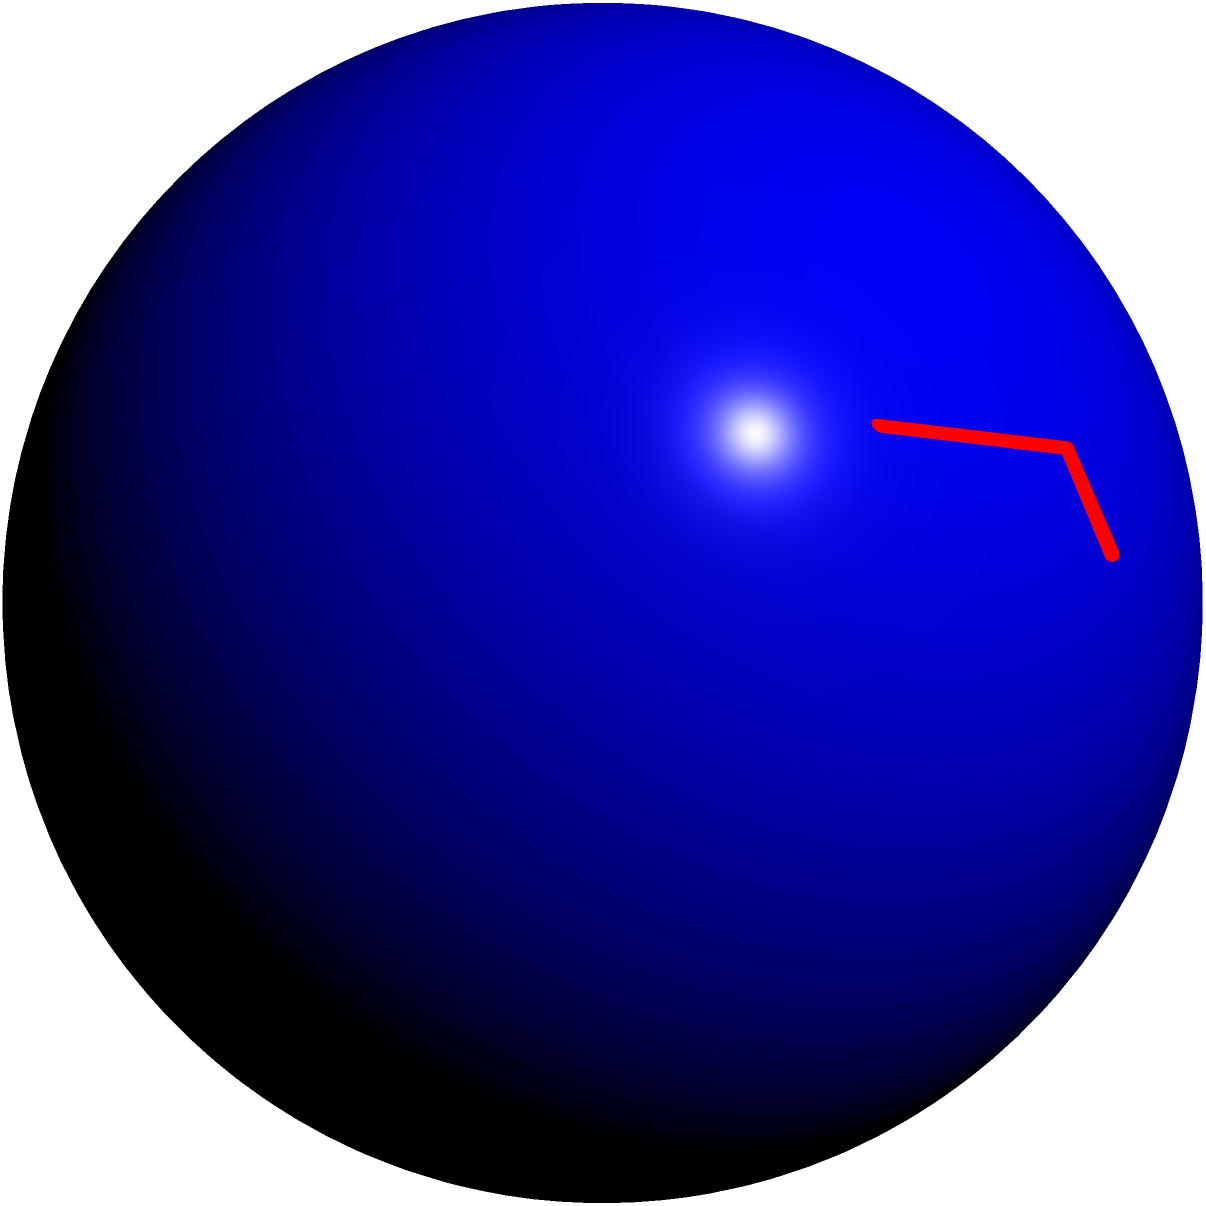In the 3D model of an antigen-antibody complex shown above, which molecular interaction is represented by the green dashed lines, and how does it contribute to the specificity and strength of the antigen-antibody binding? To answer this question, let's analyze the 3D model step-by-step:

1. The blue sphere represents the antigen, which is the target molecule recognized by the antibody.

2. The red Y-shaped structure represents the antibody, which is responsible for recognizing and binding to the antigen.

3. The yellow spheres at the tips of the Y-shaped antibody structure represent the binding sites, which are specific regions on the antibody that interact with the antigen.

4. The green dashed lines connecting the binding sites to the antigen represent hydrogen bonds.

5. Hydrogen bonds are crucial in antigen-antibody interactions because:
   a. They are highly specific: The arrangement of hydrogen bond donors and acceptors must match precisely between the antigen and antibody.
   b. They contribute to the strength of binding: Although individual hydrogen bonds are relatively weak, multiple hydrogen bonds act together to create a strong overall interaction.
   c. They are reversible: This allows for the dissociation of the antigen-antibody complex when necessary.

6. The specificity of hydrogen bonding contributes to the overall specificity of antigen-antibody recognition, ensuring that antibodies bind only to their intended targets.

7. The cumulative strength of multiple hydrogen bonds, along with other non-covalent interactions (e.g., van der Waals forces, ionic interactions), provides the overall binding strength of the antigen-antibody complex.

In summary, the green dashed lines represent hydrogen bonds, which play a crucial role in both the specificity and strength of antigen-antibody binding through their precise spatial arrangement and cumulative effects.
Answer: Hydrogen bonds 